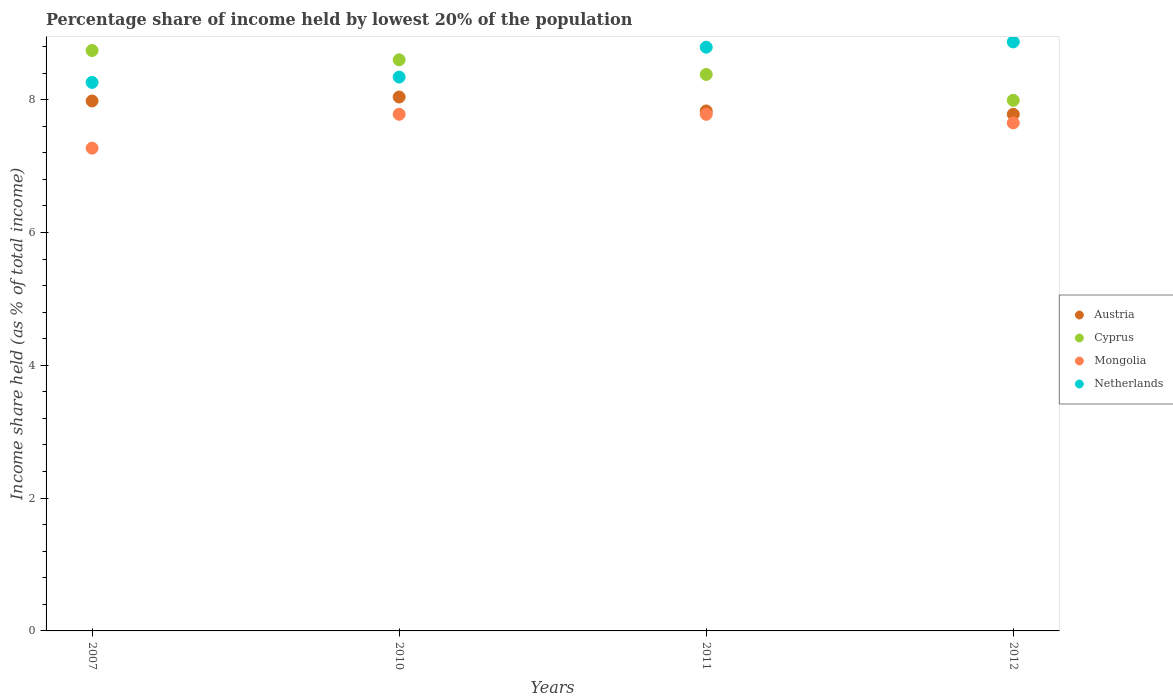Is the number of dotlines equal to the number of legend labels?
Provide a succinct answer. Yes. What is the percentage share of income held by lowest 20% of the population in Mongolia in 2012?
Provide a short and direct response. 7.65. Across all years, what is the maximum percentage share of income held by lowest 20% of the population in Cyprus?
Your answer should be compact. 8.74. Across all years, what is the minimum percentage share of income held by lowest 20% of the population in Cyprus?
Your answer should be very brief. 7.99. In which year was the percentage share of income held by lowest 20% of the population in Austria minimum?
Offer a very short reply. 2012. What is the total percentage share of income held by lowest 20% of the population in Netherlands in the graph?
Your answer should be compact. 34.26. What is the difference between the percentage share of income held by lowest 20% of the population in Mongolia in 2007 and that in 2011?
Provide a short and direct response. -0.51. What is the difference between the percentage share of income held by lowest 20% of the population in Mongolia in 2011 and the percentage share of income held by lowest 20% of the population in Austria in 2010?
Your answer should be compact. -0.26. What is the average percentage share of income held by lowest 20% of the population in Netherlands per year?
Offer a terse response. 8.56. In the year 2012, what is the difference between the percentage share of income held by lowest 20% of the population in Cyprus and percentage share of income held by lowest 20% of the population in Austria?
Ensure brevity in your answer.  0.21. What is the ratio of the percentage share of income held by lowest 20% of the population in Netherlands in 2011 to that in 2012?
Offer a terse response. 0.99. Is the difference between the percentage share of income held by lowest 20% of the population in Cyprus in 2011 and 2012 greater than the difference between the percentage share of income held by lowest 20% of the population in Austria in 2011 and 2012?
Make the answer very short. Yes. What is the difference between the highest and the second highest percentage share of income held by lowest 20% of the population in Austria?
Your response must be concise. 0.06. What is the difference between the highest and the lowest percentage share of income held by lowest 20% of the population in Mongolia?
Provide a succinct answer. 0.51. In how many years, is the percentage share of income held by lowest 20% of the population in Netherlands greater than the average percentage share of income held by lowest 20% of the population in Netherlands taken over all years?
Ensure brevity in your answer.  2. Is it the case that in every year, the sum of the percentage share of income held by lowest 20% of the population in Netherlands and percentage share of income held by lowest 20% of the population in Austria  is greater than the sum of percentage share of income held by lowest 20% of the population in Mongolia and percentage share of income held by lowest 20% of the population in Cyprus?
Give a very brief answer. Yes. Is it the case that in every year, the sum of the percentage share of income held by lowest 20% of the population in Austria and percentage share of income held by lowest 20% of the population in Netherlands  is greater than the percentage share of income held by lowest 20% of the population in Cyprus?
Offer a very short reply. Yes. Does the percentage share of income held by lowest 20% of the population in Cyprus monotonically increase over the years?
Ensure brevity in your answer.  No. Is the percentage share of income held by lowest 20% of the population in Cyprus strictly greater than the percentage share of income held by lowest 20% of the population in Mongolia over the years?
Ensure brevity in your answer.  Yes. Is the percentage share of income held by lowest 20% of the population in Netherlands strictly less than the percentage share of income held by lowest 20% of the population in Austria over the years?
Offer a very short reply. No. How many dotlines are there?
Offer a very short reply. 4. What is the difference between two consecutive major ticks on the Y-axis?
Give a very brief answer. 2. Are the values on the major ticks of Y-axis written in scientific E-notation?
Your response must be concise. No. Does the graph contain any zero values?
Ensure brevity in your answer.  No. What is the title of the graph?
Offer a terse response. Percentage share of income held by lowest 20% of the population. Does "Maldives" appear as one of the legend labels in the graph?
Give a very brief answer. No. What is the label or title of the X-axis?
Make the answer very short. Years. What is the label or title of the Y-axis?
Your answer should be compact. Income share held (as % of total income). What is the Income share held (as % of total income) in Austria in 2007?
Provide a succinct answer. 7.98. What is the Income share held (as % of total income) of Cyprus in 2007?
Provide a short and direct response. 8.74. What is the Income share held (as % of total income) in Mongolia in 2007?
Your answer should be compact. 7.27. What is the Income share held (as % of total income) in Netherlands in 2007?
Give a very brief answer. 8.26. What is the Income share held (as % of total income) in Austria in 2010?
Keep it short and to the point. 8.04. What is the Income share held (as % of total income) of Cyprus in 2010?
Offer a terse response. 8.6. What is the Income share held (as % of total income) in Mongolia in 2010?
Offer a very short reply. 7.78. What is the Income share held (as % of total income) of Netherlands in 2010?
Make the answer very short. 8.34. What is the Income share held (as % of total income) of Austria in 2011?
Ensure brevity in your answer.  7.83. What is the Income share held (as % of total income) in Cyprus in 2011?
Offer a very short reply. 8.38. What is the Income share held (as % of total income) of Mongolia in 2011?
Your response must be concise. 7.78. What is the Income share held (as % of total income) of Netherlands in 2011?
Keep it short and to the point. 8.79. What is the Income share held (as % of total income) of Austria in 2012?
Ensure brevity in your answer.  7.78. What is the Income share held (as % of total income) in Cyprus in 2012?
Ensure brevity in your answer.  7.99. What is the Income share held (as % of total income) in Mongolia in 2012?
Make the answer very short. 7.65. What is the Income share held (as % of total income) of Netherlands in 2012?
Provide a succinct answer. 8.87. Across all years, what is the maximum Income share held (as % of total income) of Austria?
Offer a terse response. 8.04. Across all years, what is the maximum Income share held (as % of total income) in Cyprus?
Your answer should be compact. 8.74. Across all years, what is the maximum Income share held (as % of total income) of Mongolia?
Make the answer very short. 7.78. Across all years, what is the maximum Income share held (as % of total income) of Netherlands?
Provide a short and direct response. 8.87. Across all years, what is the minimum Income share held (as % of total income) of Austria?
Provide a short and direct response. 7.78. Across all years, what is the minimum Income share held (as % of total income) in Cyprus?
Your response must be concise. 7.99. Across all years, what is the minimum Income share held (as % of total income) in Mongolia?
Your answer should be very brief. 7.27. Across all years, what is the minimum Income share held (as % of total income) of Netherlands?
Provide a short and direct response. 8.26. What is the total Income share held (as % of total income) in Austria in the graph?
Your response must be concise. 31.63. What is the total Income share held (as % of total income) in Cyprus in the graph?
Offer a very short reply. 33.71. What is the total Income share held (as % of total income) of Mongolia in the graph?
Your answer should be compact. 30.48. What is the total Income share held (as % of total income) of Netherlands in the graph?
Provide a short and direct response. 34.26. What is the difference between the Income share held (as % of total income) of Austria in 2007 and that in 2010?
Provide a short and direct response. -0.06. What is the difference between the Income share held (as % of total income) in Cyprus in 2007 and that in 2010?
Keep it short and to the point. 0.14. What is the difference between the Income share held (as % of total income) in Mongolia in 2007 and that in 2010?
Your answer should be compact. -0.51. What is the difference between the Income share held (as % of total income) of Netherlands in 2007 and that in 2010?
Your answer should be compact. -0.08. What is the difference between the Income share held (as % of total income) of Austria in 2007 and that in 2011?
Give a very brief answer. 0.15. What is the difference between the Income share held (as % of total income) of Cyprus in 2007 and that in 2011?
Provide a short and direct response. 0.36. What is the difference between the Income share held (as % of total income) in Mongolia in 2007 and that in 2011?
Offer a terse response. -0.51. What is the difference between the Income share held (as % of total income) of Netherlands in 2007 and that in 2011?
Ensure brevity in your answer.  -0.53. What is the difference between the Income share held (as % of total income) of Austria in 2007 and that in 2012?
Keep it short and to the point. 0.2. What is the difference between the Income share held (as % of total income) in Mongolia in 2007 and that in 2012?
Offer a very short reply. -0.38. What is the difference between the Income share held (as % of total income) in Netherlands in 2007 and that in 2012?
Make the answer very short. -0.61. What is the difference between the Income share held (as % of total income) of Austria in 2010 and that in 2011?
Your answer should be compact. 0.21. What is the difference between the Income share held (as % of total income) of Cyprus in 2010 and that in 2011?
Give a very brief answer. 0.22. What is the difference between the Income share held (as % of total income) of Mongolia in 2010 and that in 2011?
Offer a very short reply. 0. What is the difference between the Income share held (as % of total income) of Netherlands in 2010 and that in 2011?
Provide a succinct answer. -0.45. What is the difference between the Income share held (as % of total income) of Austria in 2010 and that in 2012?
Your answer should be very brief. 0.26. What is the difference between the Income share held (as % of total income) of Cyprus in 2010 and that in 2012?
Provide a short and direct response. 0.61. What is the difference between the Income share held (as % of total income) in Mongolia in 2010 and that in 2012?
Your answer should be very brief. 0.13. What is the difference between the Income share held (as % of total income) of Netherlands in 2010 and that in 2012?
Make the answer very short. -0.53. What is the difference between the Income share held (as % of total income) in Austria in 2011 and that in 2012?
Your answer should be compact. 0.05. What is the difference between the Income share held (as % of total income) in Cyprus in 2011 and that in 2012?
Provide a short and direct response. 0.39. What is the difference between the Income share held (as % of total income) in Mongolia in 2011 and that in 2012?
Provide a succinct answer. 0.13. What is the difference between the Income share held (as % of total income) in Netherlands in 2011 and that in 2012?
Offer a very short reply. -0.08. What is the difference between the Income share held (as % of total income) in Austria in 2007 and the Income share held (as % of total income) in Cyprus in 2010?
Your answer should be compact. -0.62. What is the difference between the Income share held (as % of total income) of Austria in 2007 and the Income share held (as % of total income) of Mongolia in 2010?
Your response must be concise. 0.2. What is the difference between the Income share held (as % of total income) in Austria in 2007 and the Income share held (as % of total income) in Netherlands in 2010?
Make the answer very short. -0.36. What is the difference between the Income share held (as % of total income) in Cyprus in 2007 and the Income share held (as % of total income) in Mongolia in 2010?
Provide a short and direct response. 0.96. What is the difference between the Income share held (as % of total income) of Cyprus in 2007 and the Income share held (as % of total income) of Netherlands in 2010?
Provide a short and direct response. 0.4. What is the difference between the Income share held (as % of total income) of Mongolia in 2007 and the Income share held (as % of total income) of Netherlands in 2010?
Offer a terse response. -1.07. What is the difference between the Income share held (as % of total income) in Austria in 2007 and the Income share held (as % of total income) in Netherlands in 2011?
Offer a very short reply. -0.81. What is the difference between the Income share held (as % of total income) in Cyprus in 2007 and the Income share held (as % of total income) in Mongolia in 2011?
Offer a terse response. 0.96. What is the difference between the Income share held (as % of total income) of Cyprus in 2007 and the Income share held (as % of total income) of Netherlands in 2011?
Provide a short and direct response. -0.05. What is the difference between the Income share held (as % of total income) of Mongolia in 2007 and the Income share held (as % of total income) of Netherlands in 2011?
Offer a very short reply. -1.52. What is the difference between the Income share held (as % of total income) in Austria in 2007 and the Income share held (as % of total income) in Cyprus in 2012?
Make the answer very short. -0.01. What is the difference between the Income share held (as % of total income) in Austria in 2007 and the Income share held (as % of total income) in Mongolia in 2012?
Provide a short and direct response. 0.33. What is the difference between the Income share held (as % of total income) of Austria in 2007 and the Income share held (as % of total income) of Netherlands in 2012?
Your answer should be very brief. -0.89. What is the difference between the Income share held (as % of total income) of Cyprus in 2007 and the Income share held (as % of total income) of Mongolia in 2012?
Your response must be concise. 1.09. What is the difference between the Income share held (as % of total income) in Cyprus in 2007 and the Income share held (as % of total income) in Netherlands in 2012?
Make the answer very short. -0.13. What is the difference between the Income share held (as % of total income) of Mongolia in 2007 and the Income share held (as % of total income) of Netherlands in 2012?
Your response must be concise. -1.6. What is the difference between the Income share held (as % of total income) in Austria in 2010 and the Income share held (as % of total income) in Cyprus in 2011?
Make the answer very short. -0.34. What is the difference between the Income share held (as % of total income) of Austria in 2010 and the Income share held (as % of total income) of Mongolia in 2011?
Offer a terse response. 0.26. What is the difference between the Income share held (as % of total income) in Austria in 2010 and the Income share held (as % of total income) in Netherlands in 2011?
Offer a very short reply. -0.75. What is the difference between the Income share held (as % of total income) of Cyprus in 2010 and the Income share held (as % of total income) of Mongolia in 2011?
Make the answer very short. 0.82. What is the difference between the Income share held (as % of total income) of Cyprus in 2010 and the Income share held (as % of total income) of Netherlands in 2011?
Provide a short and direct response. -0.19. What is the difference between the Income share held (as % of total income) of Mongolia in 2010 and the Income share held (as % of total income) of Netherlands in 2011?
Offer a terse response. -1.01. What is the difference between the Income share held (as % of total income) in Austria in 2010 and the Income share held (as % of total income) in Mongolia in 2012?
Keep it short and to the point. 0.39. What is the difference between the Income share held (as % of total income) in Austria in 2010 and the Income share held (as % of total income) in Netherlands in 2012?
Ensure brevity in your answer.  -0.83. What is the difference between the Income share held (as % of total income) in Cyprus in 2010 and the Income share held (as % of total income) in Netherlands in 2012?
Offer a very short reply. -0.27. What is the difference between the Income share held (as % of total income) of Mongolia in 2010 and the Income share held (as % of total income) of Netherlands in 2012?
Provide a succinct answer. -1.09. What is the difference between the Income share held (as % of total income) of Austria in 2011 and the Income share held (as % of total income) of Cyprus in 2012?
Provide a short and direct response. -0.16. What is the difference between the Income share held (as % of total income) in Austria in 2011 and the Income share held (as % of total income) in Mongolia in 2012?
Your answer should be compact. 0.18. What is the difference between the Income share held (as % of total income) of Austria in 2011 and the Income share held (as % of total income) of Netherlands in 2012?
Offer a terse response. -1.04. What is the difference between the Income share held (as % of total income) of Cyprus in 2011 and the Income share held (as % of total income) of Mongolia in 2012?
Keep it short and to the point. 0.73. What is the difference between the Income share held (as % of total income) of Cyprus in 2011 and the Income share held (as % of total income) of Netherlands in 2012?
Keep it short and to the point. -0.49. What is the difference between the Income share held (as % of total income) in Mongolia in 2011 and the Income share held (as % of total income) in Netherlands in 2012?
Your answer should be very brief. -1.09. What is the average Income share held (as % of total income) in Austria per year?
Provide a succinct answer. 7.91. What is the average Income share held (as % of total income) of Cyprus per year?
Make the answer very short. 8.43. What is the average Income share held (as % of total income) of Mongolia per year?
Your answer should be compact. 7.62. What is the average Income share held (as % of total income) in Netherlands per year?
Keep it short and to the point. 8.56. In the year 2007, what is the difference between the Income share held (as % of total income) of Austria and Income share held (as % of total income) of Cyprus?
Make the answer very short. -0.76. In the year 2007, what is the difference between the Income share held (as % of total income) in Austria and Income share held (as % of total income) in Mongolia?
Make the answer very short. 0.71. In the year 2007, what is the difference between the Income share held (as % of total income) in Austria and Income share held (as % of total income) in Netherlands?
Your answer should be compact. -0.28. In the year 2007, what is the difference between the Income share held (as % of total income) in Cyprus and Income share held (as % of total income) in Mongolia?
Make the answer very short. 1.47. In the year 2007, what is the difference between the Income share held (as % of total income) in Cyprus and Income share held (as % of total income) in Netherlands?
Your response must be concise. 0.48. In the year 2007, what is the difference between the Income share held (as % of total income) in Mongolia and Income share held (as % of total income) in Netherlands?
Provide a short and direct response. -0.99. In the year 2010, what is the difference between the Income share held (as % of total income) in Austria and Income share held (as % of total income) in Cyprus?
Your answer should be very brief. -0.56. In the year 2010, what is the difference between the Income share held (as % of total income) of Austria and Income share held (as % of total income) of Mongolia?
Your answer should be very brief. 0.26. In the year 2010, what is the difference between the Income share held (as % of total income) of Austria and Income share held (as % of total income) of Netherlands?
Ensure brevity in your answer.  -0.3. In the year 2010, what is the difference between the Income share held (as % of total income) in Cyprus and Income share held (as % of total income) in Mongolia?
Keep it short and to the point. 0.82. In the year 2010, what is the difference between the Income share held (as % of total income) in Cyprus and Income share held (as % of total income) in Netherlands?
Your answer should be very brief. 0.26. In the year 2010, what is the difference between the Income share held (as % of total income) in Mongolia and Income share held (as % of total income) in Netherlands?
Offer a terse response. -0.56. In the year 2011, what is the difference between the Income share held (as % of total income) in Austria and Income share held (as % of total income) in Cyprus?
Keep it short and to the point. -0.55. In the year 2011, what is the difference between the Income share held (as % of total income) in Austria and Income share held (as % of total income) in Netherlands?
Ensure brevity in your answer.  -0.96. In the year 2011, what is the difference between the Income share held (as % of total income) of Cyprus and Income share held (as % of total income) of Mongolia?
Ensure brevity in your answer.  0.6. In the year 2011, what is the difference between the Income share held (as % of total income) of Cyprus and Income share held (as % of total income) of Netherlands?
Offer a terse response. -0.41. In the year 2011, what is the difference between the Income share held (as % of total income) in Mongolia and Income share held (as % of total income) in Netherlands?
Provide a succinct answer. -1.01. In the year 2012, what is the difference between the Income share held (as % of total income) in Austria and Income share held (as % of total income) in Cyprus?
Provide a short and direct response. -0.21. In the year 2012, what is the difference between the Income share held (as % of total income) of Austria and Income share held (as % of total income) of Mongolia?
Give a very brief answer. 0.13. In the year 2012, what is the difference between the Income share held (as % of total income) in Austria and Income share held (as % of total income) in Netherlands?
Make the answer very short. -1.09. In the year 2012, what is the difference between the Income share held (as % of total income) of Cyprus and Income share held (as % of total income) of Mongolia?
Your response must be concise. 0.34. In the year 2012, what is the difference between the Income share held (as % of total income) in Cyprus and Income share held (as % of total income) in Netherlands?
Offer a terse response. -0.88. In the year 2012, what is the difference between the Income share held (as % of total income) of Mongolia and Income share held (as % of total income) of Netherlands?
Make the answer very short. -1.22. What is the ratio of the Income share held (as % of total income) of Cyprus in 2007 to that in 2010?
Your response must be concise. 1.02. What is the ratio of the Income share held (as % of total income) in Mongolia in 2007 to that in 2010?
Your response must be concise. 0.93. What is the ratio of the Income share held (as % of total income) in Netherlands in 2007 to that in 2010?
Your answer should be compact. 0.99. What is the ratio of the Income share held (as % of total income) of Austria in 2007 to that in 2011?
Your response must be concise. 1.02. What is the ratio of the Income share held (as % of total income) in Cyprus in 2007 to that in 2011?
Provide a short and direct response. 1.04. What is the ratio of the Income share held (as % of total income) in Mongolia in 2007 to that in 2011?
Your response must be concise. 0.93. What is the ratio of the Income share held (as % of total income) in Netherlands in 2007 to that in 2011?
Your response must be concise. 0.94. What is the ratio of the Income share held (as % of total income) of Austria in 2007 to that in 2012?
Ensure brevity in your answer.  1.03. What is the ratio of the Income share held (as % of total income) in Cyprus in 2007 to that in 2012?
Make the answer very short. 1.09. What is the ratio of the Income share held (as % of total income) in Mongolia in 2007 to that in 2012?
Ensure brevity in your answer.  0.95. What is the ratio of the Income share held (as % of total income) of Netherlands in 2007 to that in 2012?
Your response must be concise. 0.93. What is the ratio of the Income share held (as % of total income) of Austria in 2010 to that in 2011?
Your answer should be very brief. 1.03. What is the ratio of the Income share held (as % of total income) in Cyprus in 2010 to that in 2011?
Offer a very short reply. 1.03. What is the ratio of the Income share held (as % of total income) in Mongolia in 2010 to that in 2011?
Offer a very short reply. 1. What is the ratio of the Income share held (as % of total income) in Netherlands in 2010 to that in 2011?
Your answer should be very brief. 0.95. What is the ratio of the Income share held (as % of total income) in Austria in 2010 to that in 2012?
Your response must be concise. 1.03. What is the ratio of the Income share held (as % of total income) in Cyprus in 2010 to that in 2012?
Give a very brief answer. 1.08. What is the ratio of the Income share held (as % of total income) in Netherlands in 2010 to that in 2012?
Your answer should be compact. 0.94. What is the ratio of the Income share held (as % of total income) of Austria in 2011 to that in 2012?
Offer a terse response. 1.01. What is the ratio of the Income share held (as % of total income) in Cyprus in 2011 to that in 2012?
Your answer should be very brief. 1.05. What is the difference between the highest and the second highest Income share held (as % of total income) in Austria?
Offer a terse response. 0.06. What is the difference between the highest and the second highest Income share held (as % of total income) in Cyprus?
Provide a succinct answer. 0.14. What is the difference between the highest and the second highest Income share held (as % of total income) of Netherlands?
Keep it short and to the point. 0.08. What is the difference between the highest and the lowest Income share held (as % of total income) of Austria?
Give a very brief answer. 0.26. What is the difference between the highest and the lowest Income share held (as % of total income) in Cyprus?
Your answer should be very brief. 0.75. What is the difference between the highest and the lowest Income share held (as % of total income) of Mongolia?
Your answer should be very brief. 0.51. What is the difference between the highest and the lowest Income share held (as % of total income) of Netherlands?
Ensure brevity in your answer.  0.61. 